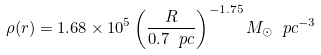<formula> <loc_0><loc_0><loc_500><loc_500>\rho ( r ) = 1 . 6 8 \times 1 0 ^ { 5 } \left ( \frac { R } { 0 . 7 \ p c } \right ) ^ { - 1 . 7 5 } M _ { \odot } \ p c ^ { - 3 }</formula> 